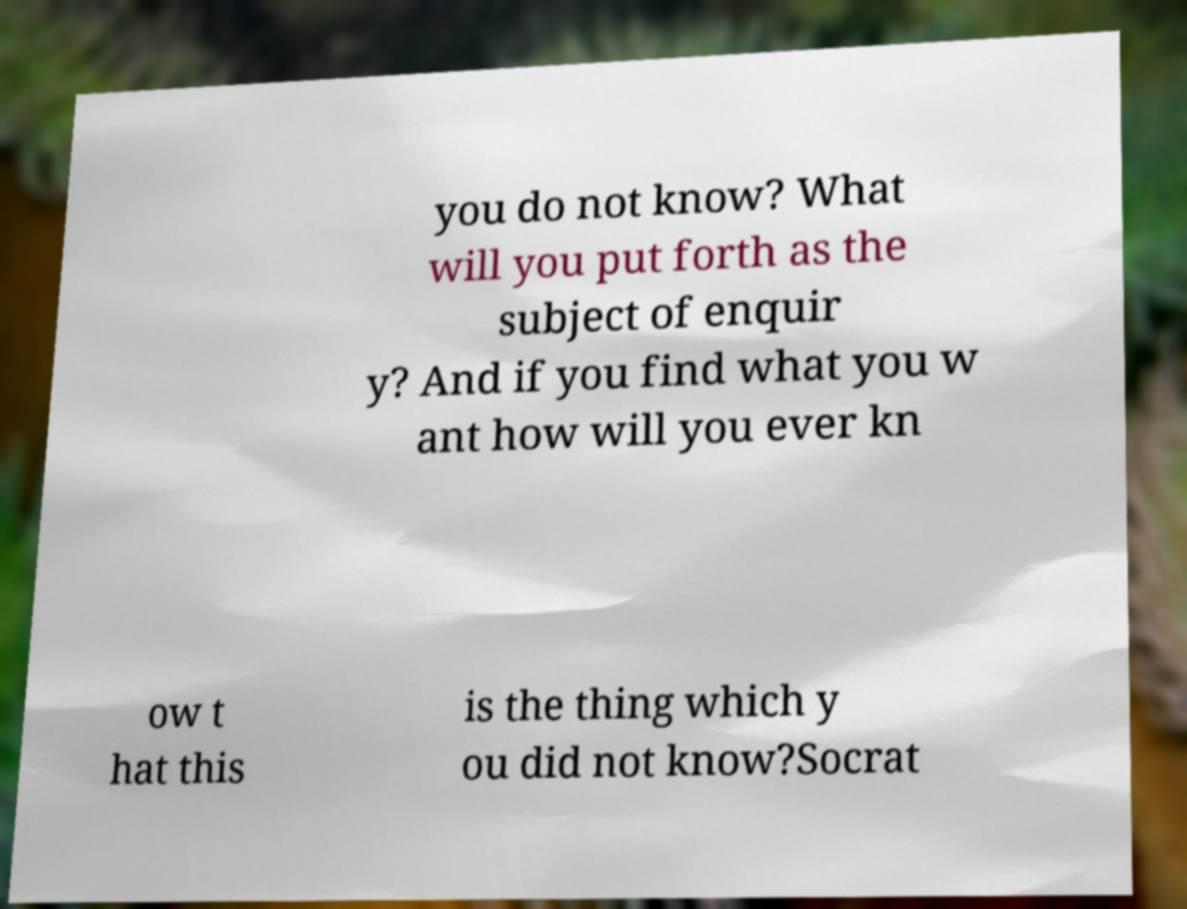Could you assist in decoding the text presented in this image and type it out clearly? you do not know? What will you put forth as the subject of enquir y? And if you find what you w ant how will you ever kn ow t hat this is the thing which y ou did not know?Socrat 